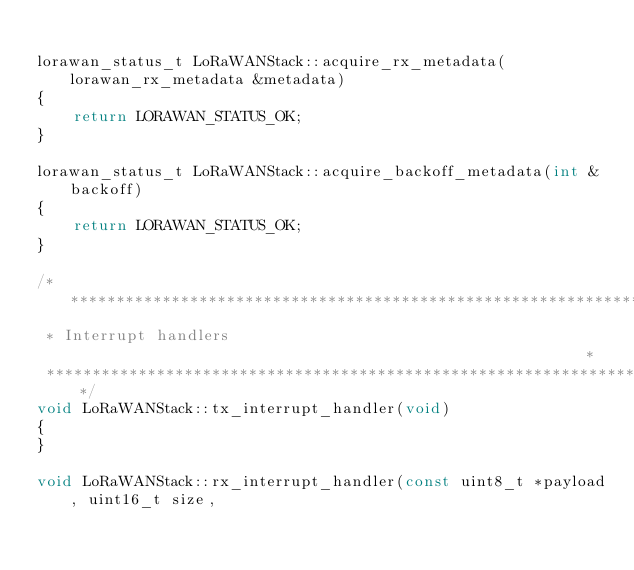Convert code to text. <code><loc_0><loc_0><loc_500><loc_500><_C++_>
lorawan_status_t LoRaWANStack::acquire_rx_metadata(lorawan_rx_metadata &metadata)
{
    return LORAWAN_STATUS_OK;
}

lorawan_status_t LoRaWANStack::acquire_backoff_metadata(int &backoff)
{
    return LORAWAN_STATUS_OK;
}

/*****************************************************************************
 * Interrupt handlers                                                        *
 ****************************************************************************/
void LoRaWANStack::tx_interrupt_handler(void)
{
}

void LoRaWANStack::rx_interrupt_handler(const uint8_t *payload, uint16_t size,</code> 